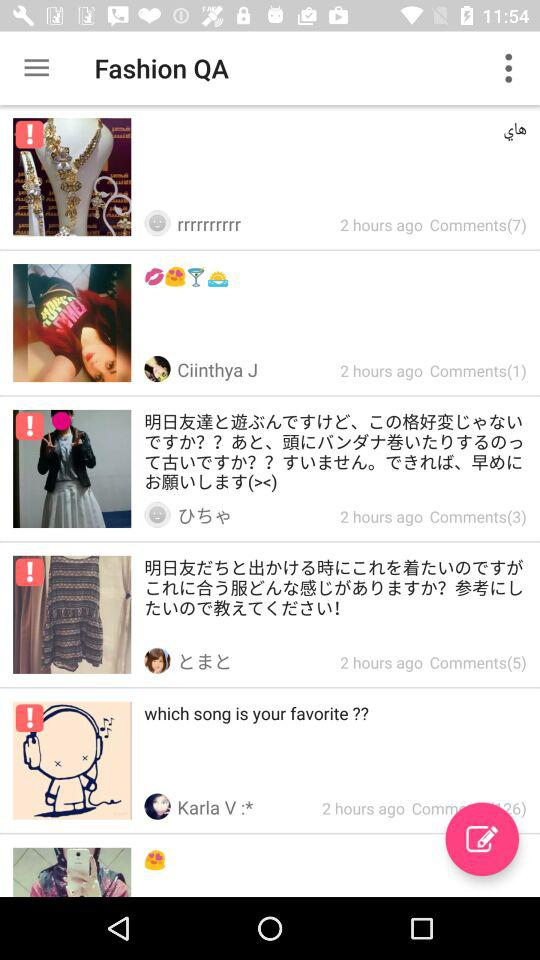How many comments does the post with the most comments have?
Answer the question using a single word or phrase. 7 